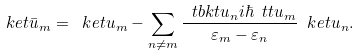Convert formula to latex. <formula><loc_0><loc_0><loc_500><loc_500>\ k e t { \bar { u } _ { m } } = \ k e t { u _ { m } } - \sum _ { n \ne m } \frac { \ t b k t { u _ { n } } { i \hbar { \ } t { t } } { u _ { m } } } { \varepsilon _ { m } - \varepsilon _ { n } } \ k e t { u _ { n } } .</formula> 